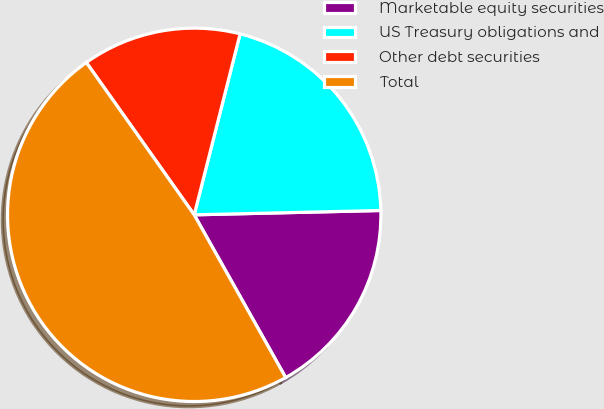<chart> <loc_0><loc_0><loc_500><loc_500><pie_chart><fcel>Marketable equity securities<fcel>US Treasury obligations and<fcel>Other debt securities<fcel>Total<nl><fcel>17.22%<fcel>20.68%<fcel>13.76%<fcel>48.35%<nl></chart> 